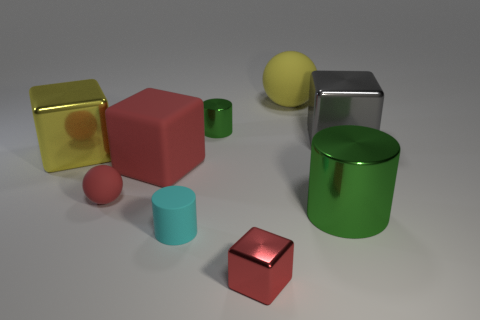How many other things are there of the same shape as the large green metal object?
Offer a very short reply. 2. Does the large green object have the same shape as the large gray object?
Your answer should be compact. No. Are there any tiny matte balls behind the gray block?
Provide a short and direct response. No. How many objects are either large yellow objects or large cyan metal blocks?
Make the answer very short. 2. What number of other things are there of the same size as the matte cube?
Provide a short and direct response. 4. What number of metallic objects are to the right of the large red matte thing and left of the large green metallic thing?
Your answer should be compact. 2. There is a cylinder that is to the right of the tiny red metal object; is its size the same as the green metal cylinder that is to the left of the yellow matte ball?
Provide a short and direct response. No. What is the size of the red object in front of the small matte cylinder?
Ensure brevity in your answer.  Small. What number of objects are shiny objects that are in front of the large red block or things to the right of the small cyan matte cylinder?
Your response must be concise. 5. Is there anything else that is the same color as the big cylinder?
Offer a terse response. Yes. 